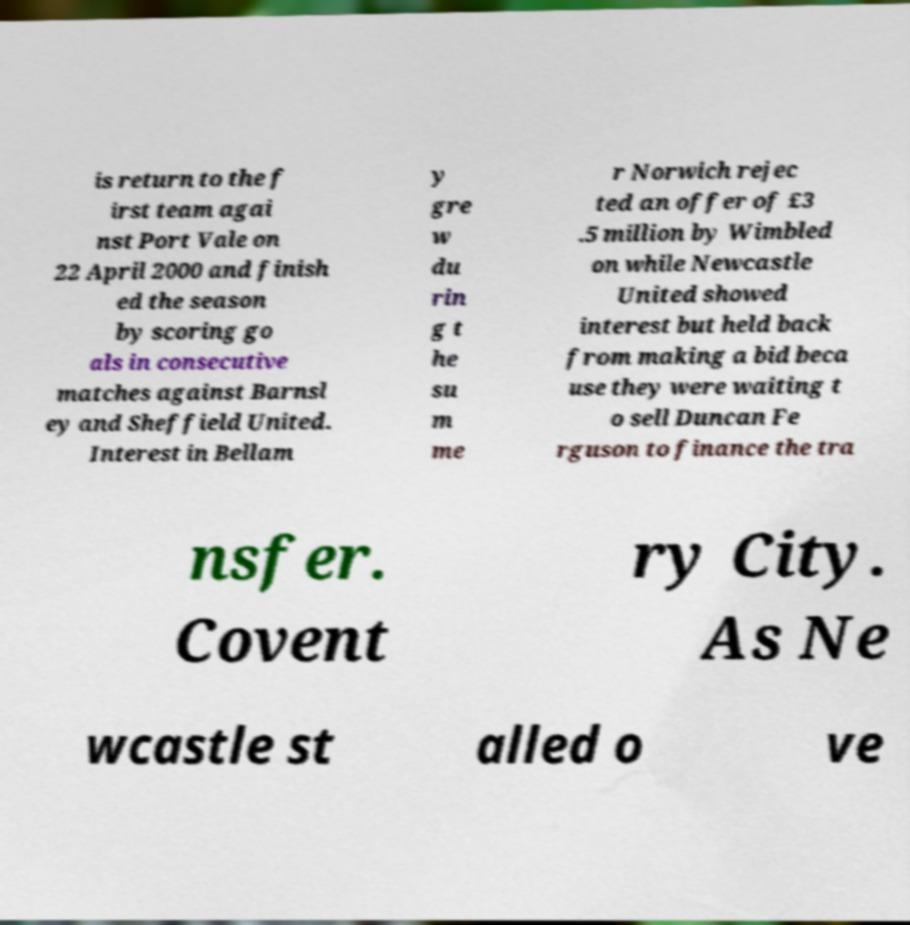Can you read and provide the text displayed in the image?This photo seems to have some interesting text. Can you extract and type it out for me? is return to the f irst team agai nst Port Vale on 22 April 2000 and finish ed the season by scoring go als in consecutive matches against Barnsl ey and Sheffield United. Interest in Bellam y gre w du rin g t he su m me r Norwich rejec ted an offer of £3 .5 million by Wimbled on while Newcastle United showed interest but held back from making a bid beca use they were waiting t o sell Duncan Fe rguson to finance the tra nsfer. Covent ry City. As Ne wcastle st alled o ve 